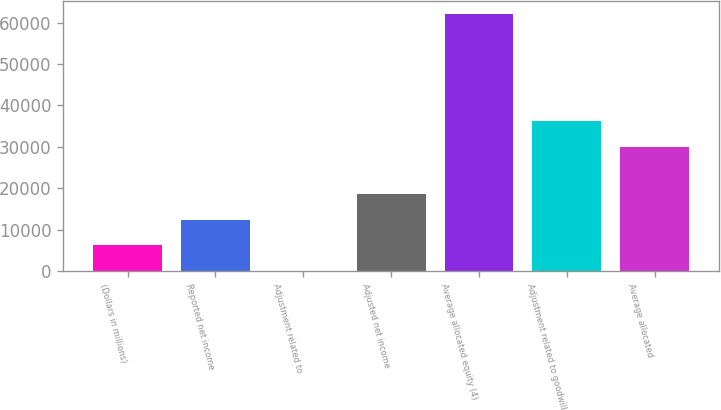Convert chart to OTSL. <chart><loc_0><loc_0><loc_500><loc_500><bar_chart><fcel>(Dollars in millions)<fcel>Reported net income<fcel>Adjustment related to<fcel>Adjusted net income<fcel>Average allocated equity (4)<fcel>Adjustment related to goodwill<fcel>Average allocated<nl><fcel>6210.8<fcel>12414.6<fcel>7<fcel>18618.4<fcel>62045<fcel>36203.8<fcel>30000<nl></chart> 